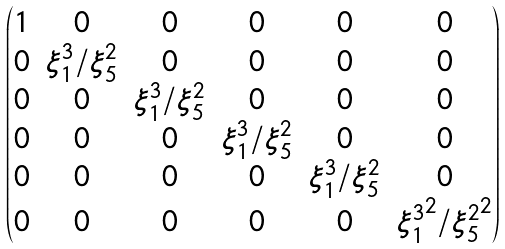Convert formula to latex. <formula><loc_0><loc_0><loc_500><loc_500>\begin{pmatrix} 1 & 0 & 0 & 0 & 0 & 0 \\ 0 & { \xi ^ { 3 } _ { 1 } } / { \xi ^ { 2 } _ { 5 } } & 0 & 0 & 0 & 0 \\ 0 & 0 & { \xi ^ { 3 } _ { 1 } } / { \xi ^ { 2 } _ { 5 } } & 0 & 0 & 0 \\ 0 & 0 & 0 & { \xi ^ { 3 } _ { 1 } } / { \xi ^ { 2 } _ { 5 } } & 0 & 0 \\ 0 & 0 & 0 & 0 & { \xi ^ { 3 } _ { 1 } } / { \xi ^ { 2 } _ { 5 } } & 0 \\ 0 & 0 & 0 & 0 & 0 & { \xi ^ { 3 } _ { 1 } } ^ { 2 } / { \xi ^ { 2 } _ { 5 } } ^ { 2 } \end{pmatrix}</formula> 